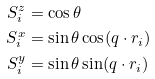Convert formula to latex. <formula><loc_0><loc_0><loc_500><loc_500>S _ { i } ^ { z } & = \cos \theta \\ S _ { i } ^ { x } & = \sin \theta \cos ( q \cdot r _ { i } ) \\ S _ { i } ^ { y } & = \sin \theta \sin ( q \cdot r _ { i } )</formula> 